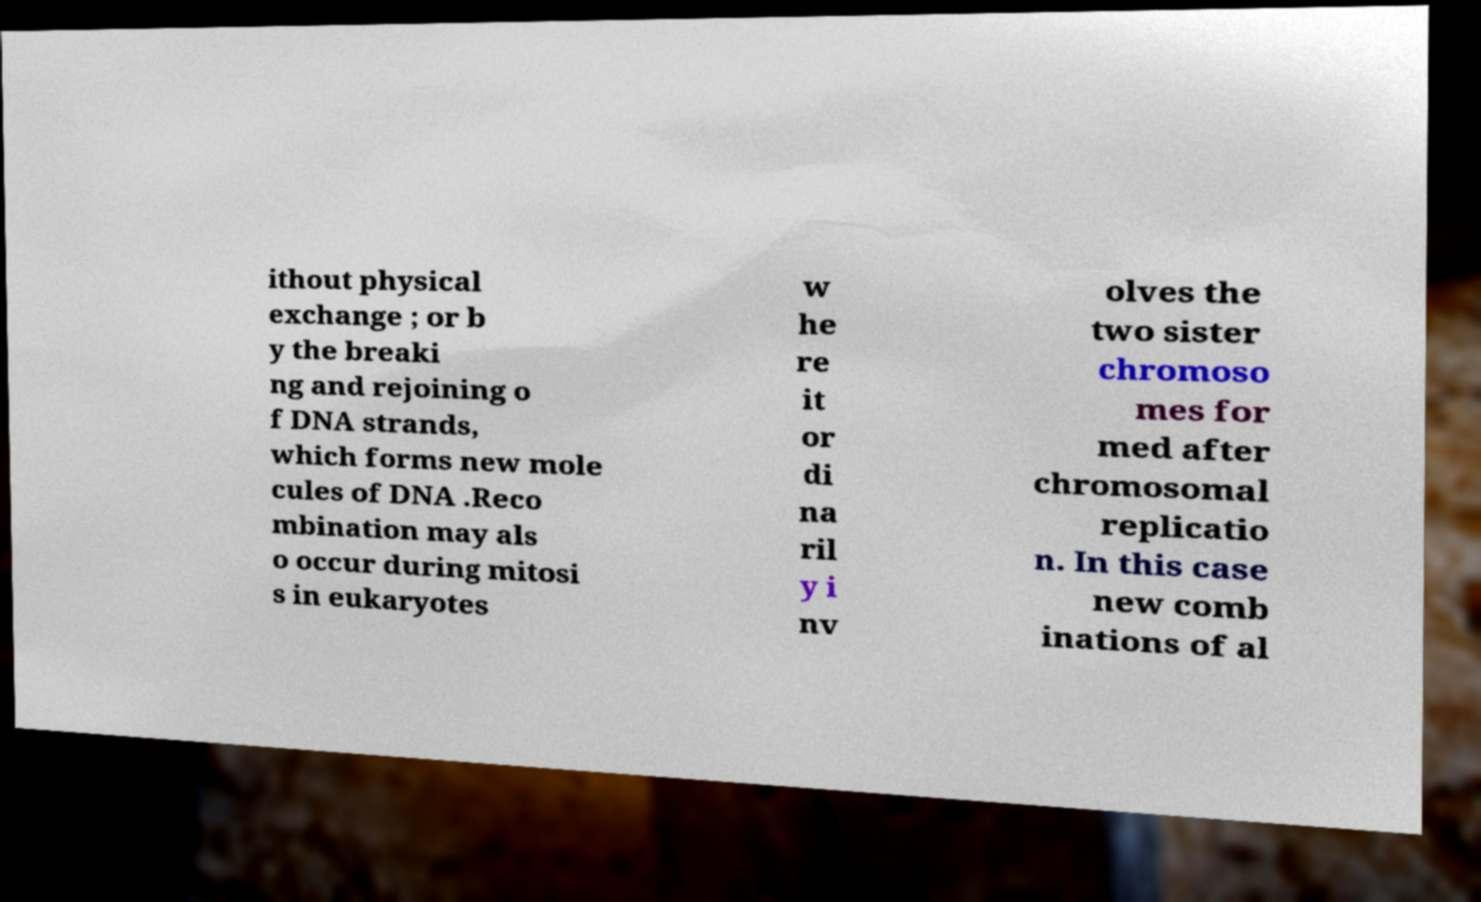Can you read and provide the text displayed in the image?This photo seems to have some interesting text. Can you extract and type it out for me? ithout physical exchange ; or b y the breaki ng and rejoining o f DNA strands, which forms new mole cules of DNA .Reco mbination may als o occur during mitosi s in eukaryotes w he re it or di na ril y i nv olves the two sister chromoso mes for med after chromosomal replicatio n. In this case new comb inations of al 